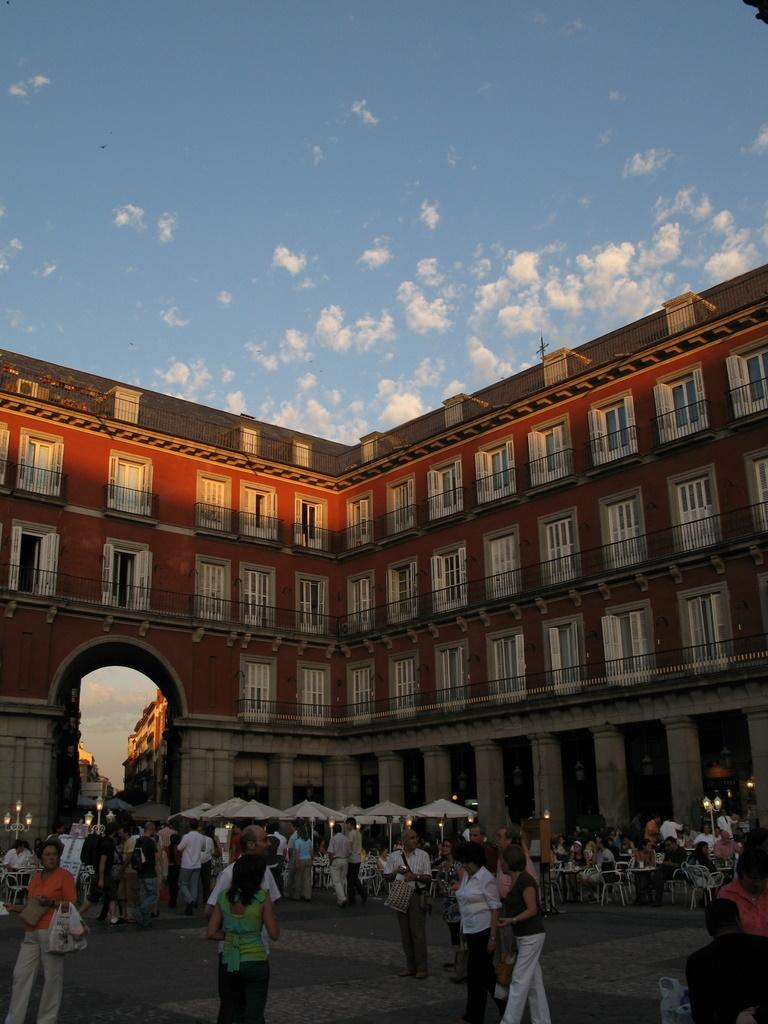What can be seen in the sky in the image? The sky with clouds is visible in the image. What type of structure is present in the image? There is a building in the image. What architectural feature can be seen in the image? There is an arch in the image. the image. What objects are used for shade in the image? Parasols are visible in the image. What are the people in the image doing? Persons sitting on chairs and persons standing on the road are in the image. What type of furniture is present in the image? Tables are present in the image. What type of lighting is visible in the image? Street lights are visible in the image. What type of apparatus is being used by the sister in the image? There is no sister or apparatus present in the image. What is the mass of the objects on the tables in the image? The mass of the objects on the tables cannot be determined from the image alone. 